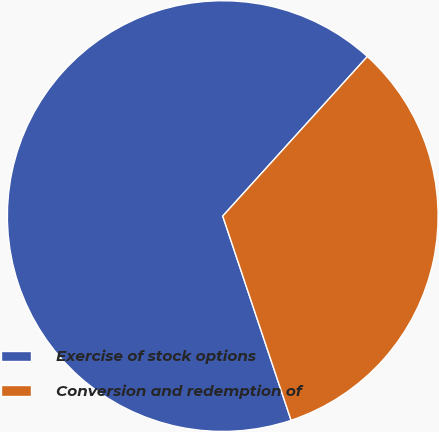Convert chart. <chart><loc_0><loc_0><loc_500><loc_500><pie_chart><fcel>Exercise of stock options<fcel>Conversion and redemption of<nl><fcel>66.86%<fcel>33.14%<nl></chart> 